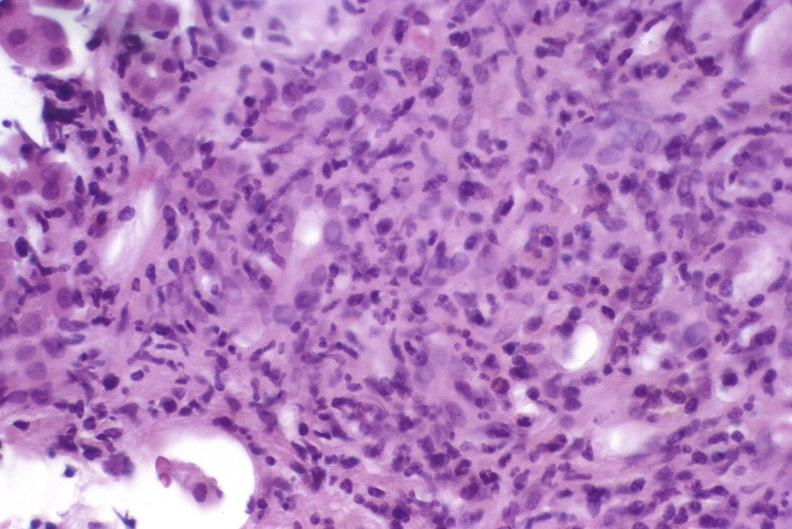does this image show autoimmune hepatitis?
Answer the question using a single word or phrase. Yes 